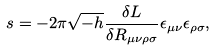<formula> <loc_0><loc_0><loc_500><loc_500>s = - 2 \pi \sqrt { - h } \frac { \delta L } { \delta R _ { \mu \nu \rho \sigma } } \epsilon _ { \mu \nu } \epsilon _ { \rho \sigma } ,</formula> 